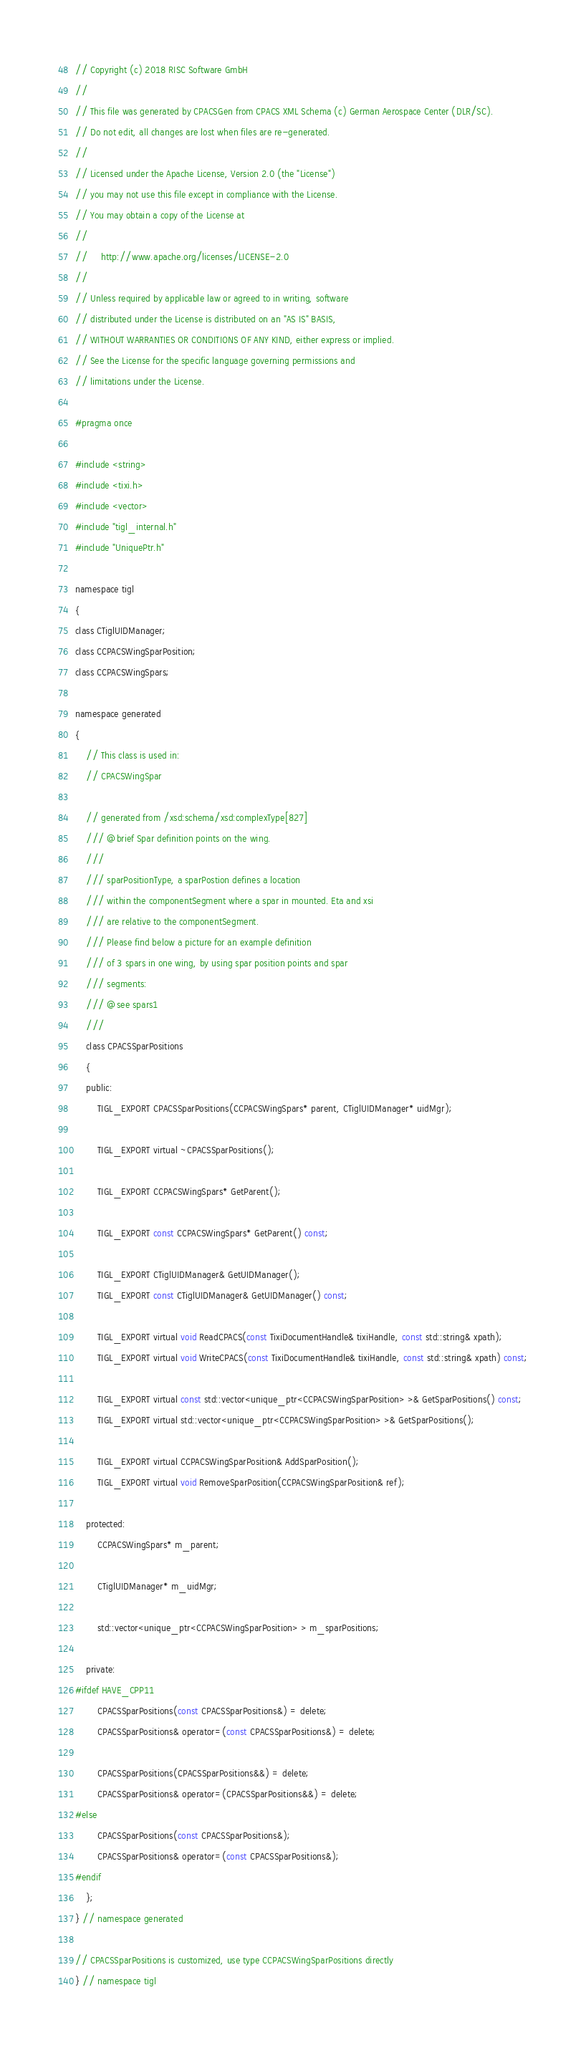Convert code to text. <code><loc_0><loc_0><loc_500><loc_500><_C_>// Copyright (c) 2018 RISC Software GmbH
//
// This file was generated by CPACSGen from CPACS XML Schema (c) German Aerospace Center (DLR/SC).
// Do not edit, all changes are lost when files are re-generated.
//
// Licensed under the Apache License, Version 2.0 (the "License")
// you may not use this file except in compliance with the License.
// You may obtain a copy of the License at
//
//     http://www.apache.org/licenses/LICENSE-2.0
//
// Unless required by applicable law or agreed to in writing, software
// distributed under the License is distributed on an "AS IS" BASIS,
// WITHOUT WARRANTIES OR CONDITIONS OF ANY KIND, either express or implied.
// See the License for the specific language governing permissions and
// limitations under the License.

#pragma once

#include <string>
#include <tixi.h>
#include <vector>
#include "tigl_internal.h"
#include "UniquePtr.h"

namespace tigl
{
class CTiglUIDManager;
class CCPACSWingSparPosition;
class CCPACSWingSpars;

namespace generated
{
    // This class is used in:
    // CPACSWingSpar

    // generated from /xsd:schema/xsd:complexType[827]
    /// @brief Spar definition points on the wing.
    /// 
    /// sparPositionType, a sparPostion defines a location
    /// within the componentSegment where a spar in mounted. Eta and xsi
    /// are relative to the componentSegment.
    /// Please find below a picture for an example definition
    /// of 3 spars in one wing, by using spar position points and spar
    /// segments:
    /// @see spars1
    /// 
    class CPACSSparPositions
    {
    public:
        TIGL_EXPORT CPACSSparPositions(CCPACSWingSpars* parent, CTiglUIDManager* uidMgr);

        TIGL_EXPORT virtual ~CPACSSparPositions();

        TIGL_EXPORT CCPACSWingSpars* GetParent();

        TIGL_EXPORT const CCPACSWingSpars* GetParent() const;

        TIGL_EXPORT CTiglUIDManager& GetUIDManager();
        TIGL_EXPORT const CTiglUIDManager& GetUIDManager() const;

        TIGL_EXPORT virtual void ReadCPACS(const TixiDocumentHandle& tixiHandle, const std::string& xpath);
        TIGL_EXPORT virtual void WriteCPACS(const TixiDocumentHandle& tixiHandle, const std::string& xpath) const;

        TIGL_EXPORT virtual const std::vector<unique_ptr<CCPACSWingSparPosition> >& GetSparPositions() const;
        TIGL_EXPORT virtual std::vector<unique_ptr<CCPACSWingSparPosition> >& GetSparPositions();

        TIGL_EXPORT virtual CCPACSWingSparPosition& AddSparPosition();
        TIGL_EXPORT virtual void RemoveSparPosition(CCPACSWingSparPosition& ref);

    protected:
        CCPACSWingSpars* m_parent;

        CTiglUIDManager* m_uidMgr;

        std::vector<unique_ptr<CCPACSWingSparPosition> > m_sparPositions;

    private:
#ifdef HAVE_CPP11
        CPACSSparPositions(const CPACSSparPositions&) = delete;
        CPACSSparPositions& operator=(const CPACSSparPositions&) = delete;

        CPACSSparPositions(CPACSSparPositions&&) = delete;
        CPACSSparPositions& operator=(CPACSSparPositions&&) = delete;
#else
        CPACSSparPositions(const CPACSSparPositions&);
        CPACSSparPositions& operator=(const CPACSSparPositions&);
#endif
    };
} // namespace generated

// CPACSSparPositions is customized, use type CCPACSWingSparPositions directly
} // namespace tigl
</code> 